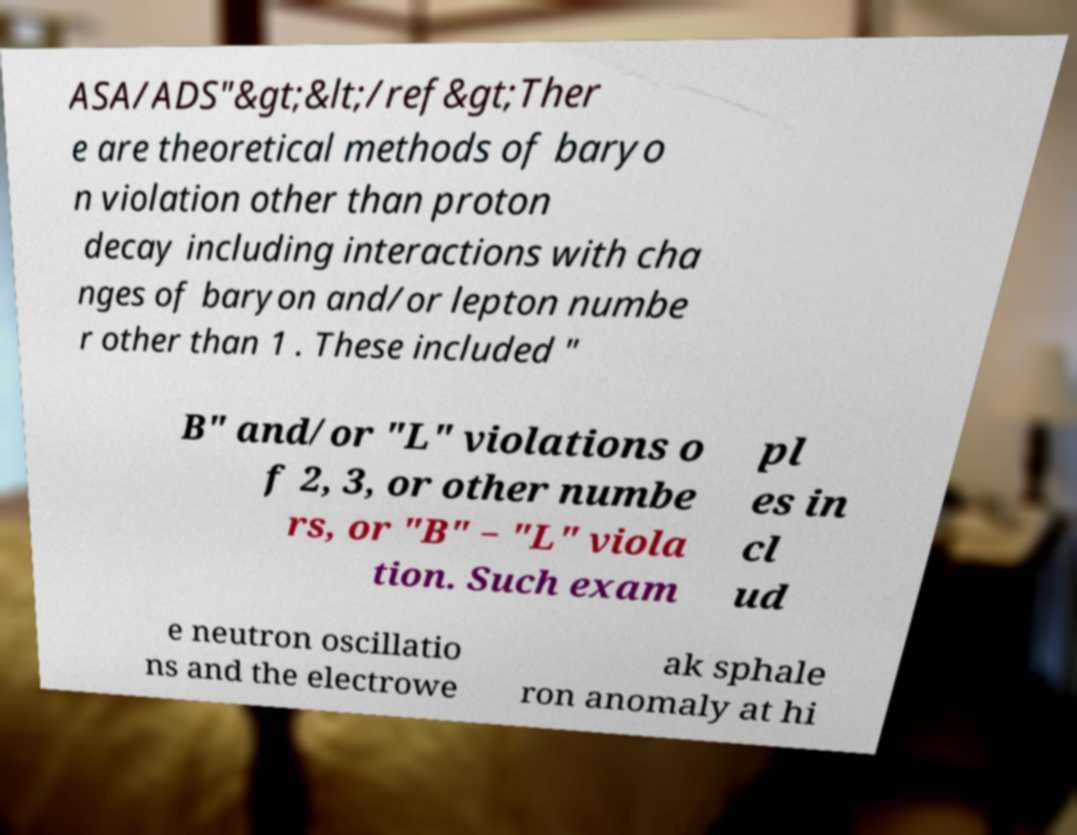Please identify and transcribe the text found in this image. ASA/ADS"&gt;&lt;/ref&gt;Ther e are theoretical methods of baryo n violation other than proton decay including interactions with cha nges of baryon and/or lepton numbe r other than 1 . These included " B" and/or "L" violations o f 2, 3, or other numbe rs, or "B" − "L" viola tion. Such exam pl es in cl ud e neutron oscillatio ns and the electrowe ak sphale ron anomaly at hi 